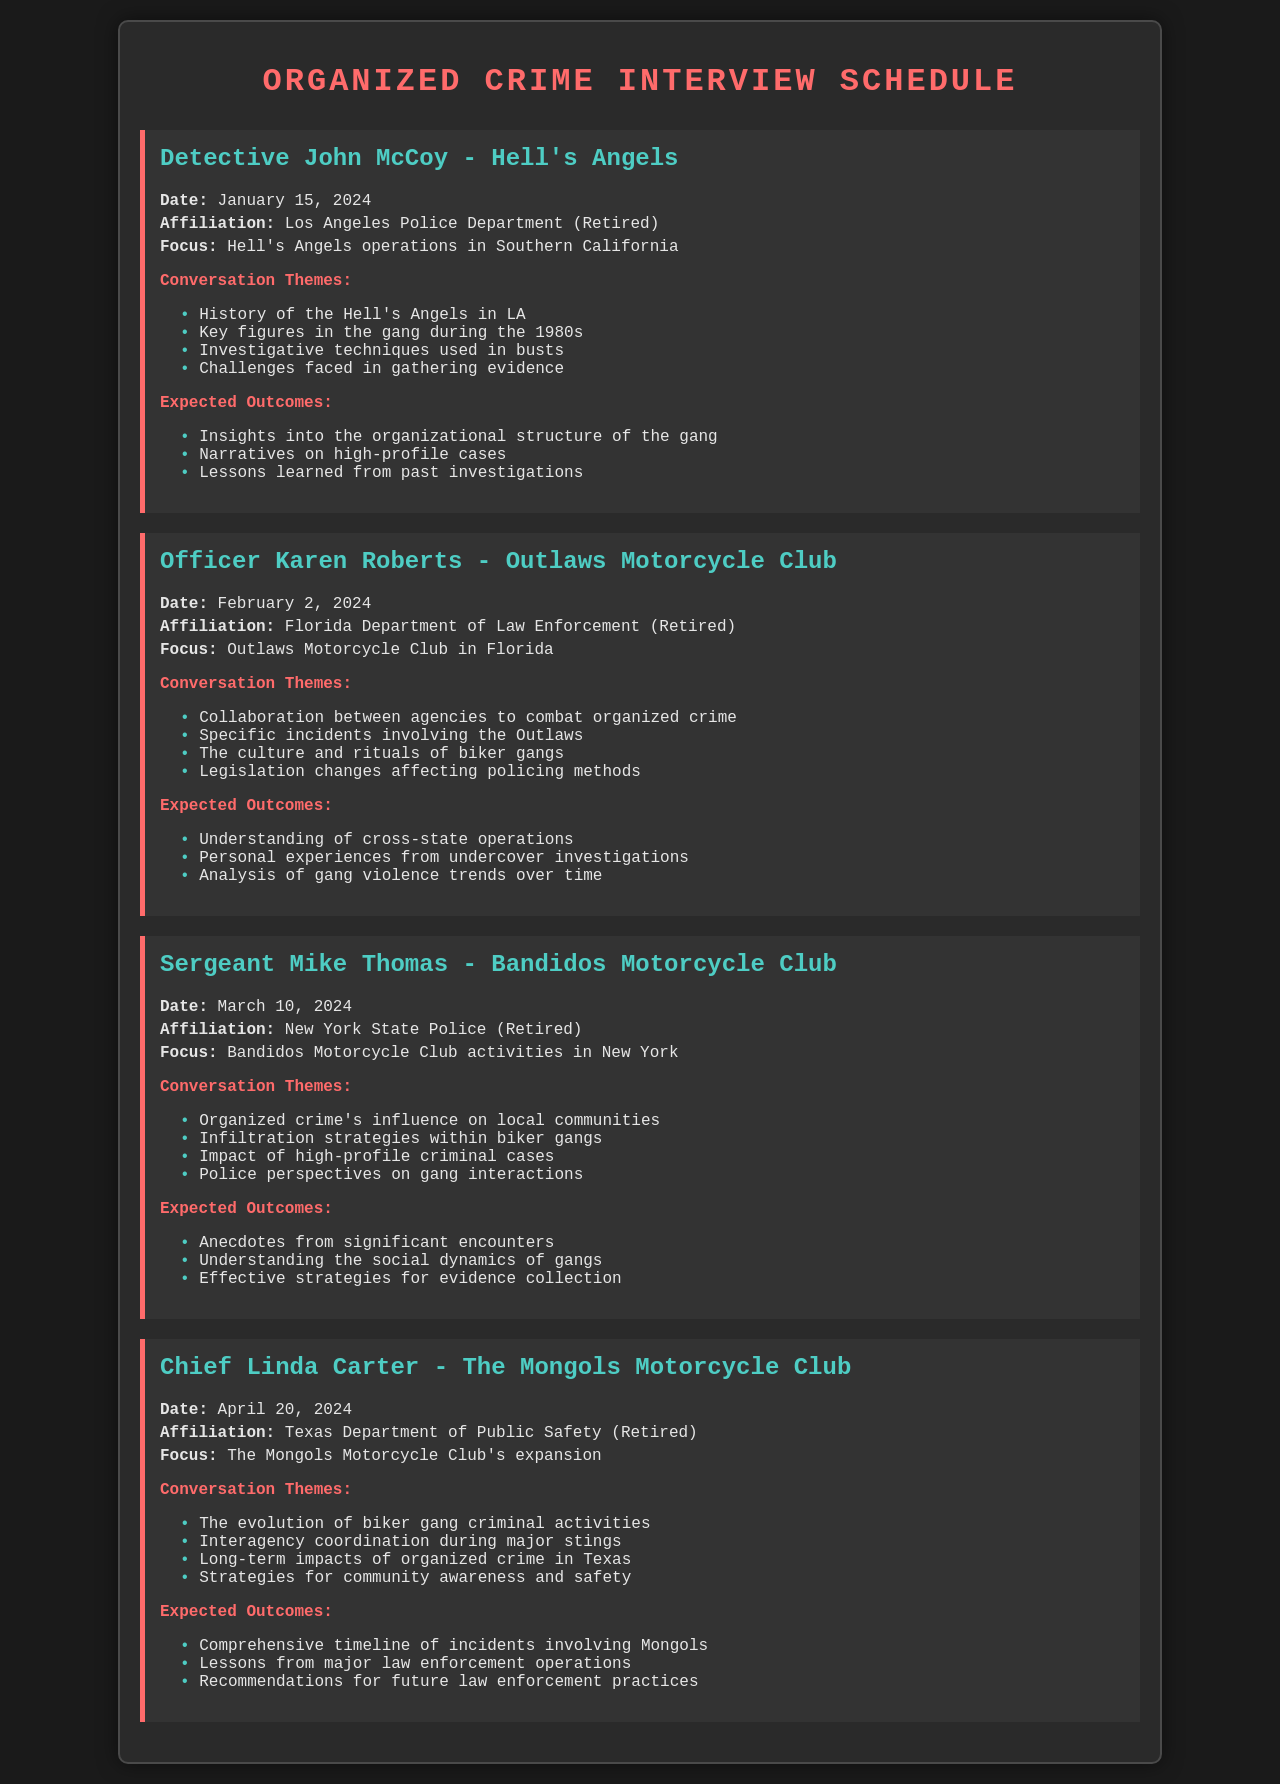what is the date of the interview with Detective John McCoy? The interview with Detective John McCoy is scheduled for January 15, 2024.
Answer: January 15, 2024 who is the retired officer focusing on the Outlaws Motorcycle Club? The retired officer focusing on the Outlaws Motorcycle Club is Officer Karen Roberts.
Answer: Officer Karen Roberts what is the main focus of Sergeant Mike Thomas's interview? The main focus of Sergeant Mike Thomas's interview is Bandidos Motorcycle Club activities in New York.
Answer: Bandidos Motorcycle Club activities in New York how many themes are listed for Chief Linda Carter's interview? Chief Linda Carter's interview lists four themes under conversation themes.
Answer: Four what is one expected outcome from the interview with Officer Karen Roberts? One expected outcome from the interview with Officer Karen Roberts is an understanding of cross-state operations.
Answer: Understanding of cross-state operations who is the interviewee for the Mongols Motorcycle Club? The interviewee for the Mongols Motorcycle Club is Chief Linda Carter.
Answer: Chief Linda Carter what investigative techniques are mentioned in the themes for Detective John McCoy? The themes for Detective John McCoy mention investigative techniques used in busts.
Answer: Investigative techniques used in busts which agency does Officer Karen Roberts have affiliation with? Officer Karen Roberts is affiliated with the Florida Department of Law Enforcement.
Answer: Florida Department of Law Enforcement when is the interview with Chief Linda Carter scheduled? The interview with Chief Linda Carter is scheduled for April 20, 2024.
Answer: April 20, 2024 